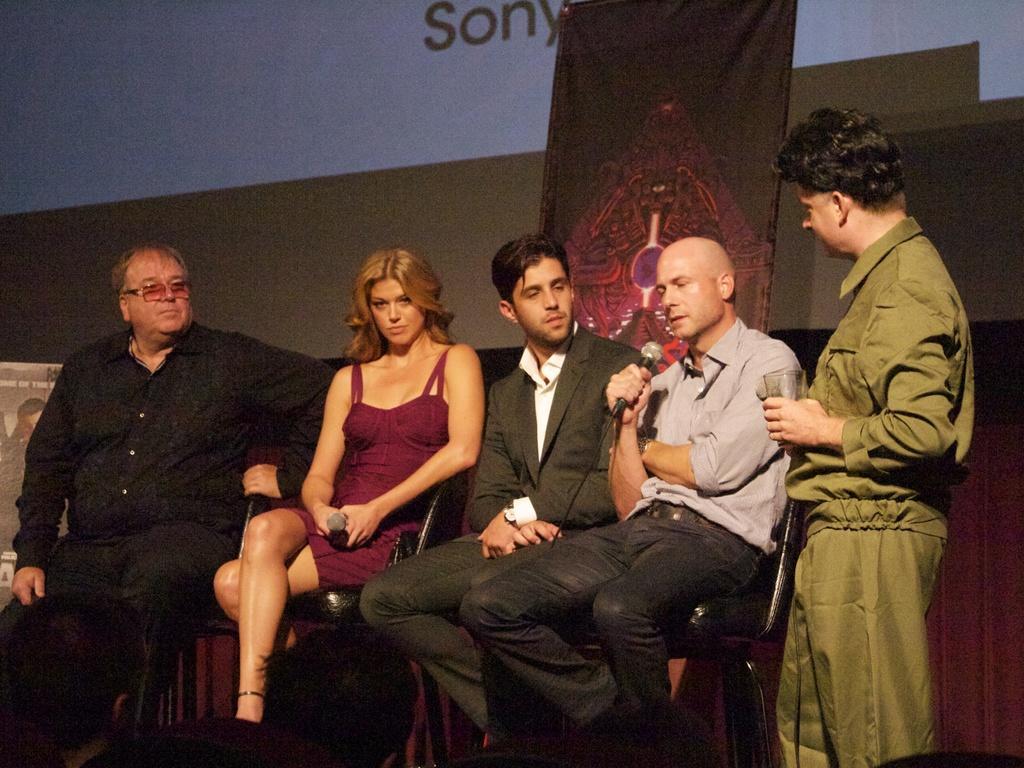Please provide a concise description of this image. In this picture, there are group of people. Among them, four people are sitting on the chairs. Towards the right, there is another man standing beside them. He is wearing green clothes and he is holding an object. Beside him, there is another man, holding a mike. In the center, there is a man wearing a blazer and a trouser. Towards the left, there is a woman and a man. In the background, there is a screen with some text. 